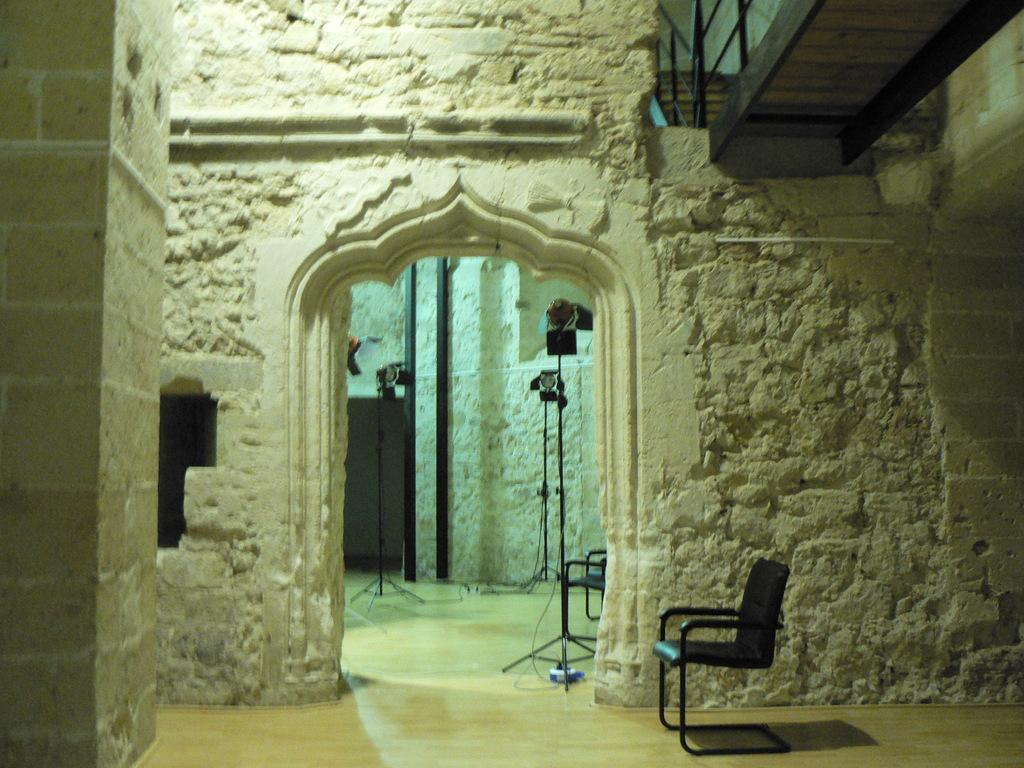What type of structure is visible in the image? There is a building in the image. What can be seen near the building? There are stands and a chair visible in the image. Is there any barrier or safety feature in the image? Yes, there is a railing in the image. What is on the floor in the image? There is an object on the floor in the image. What is the best route to take during winter to reach the building in the image? The provided facts do not mention any information about the season or the best route to reach the building, so it is not possible to answer this question based on the image. 